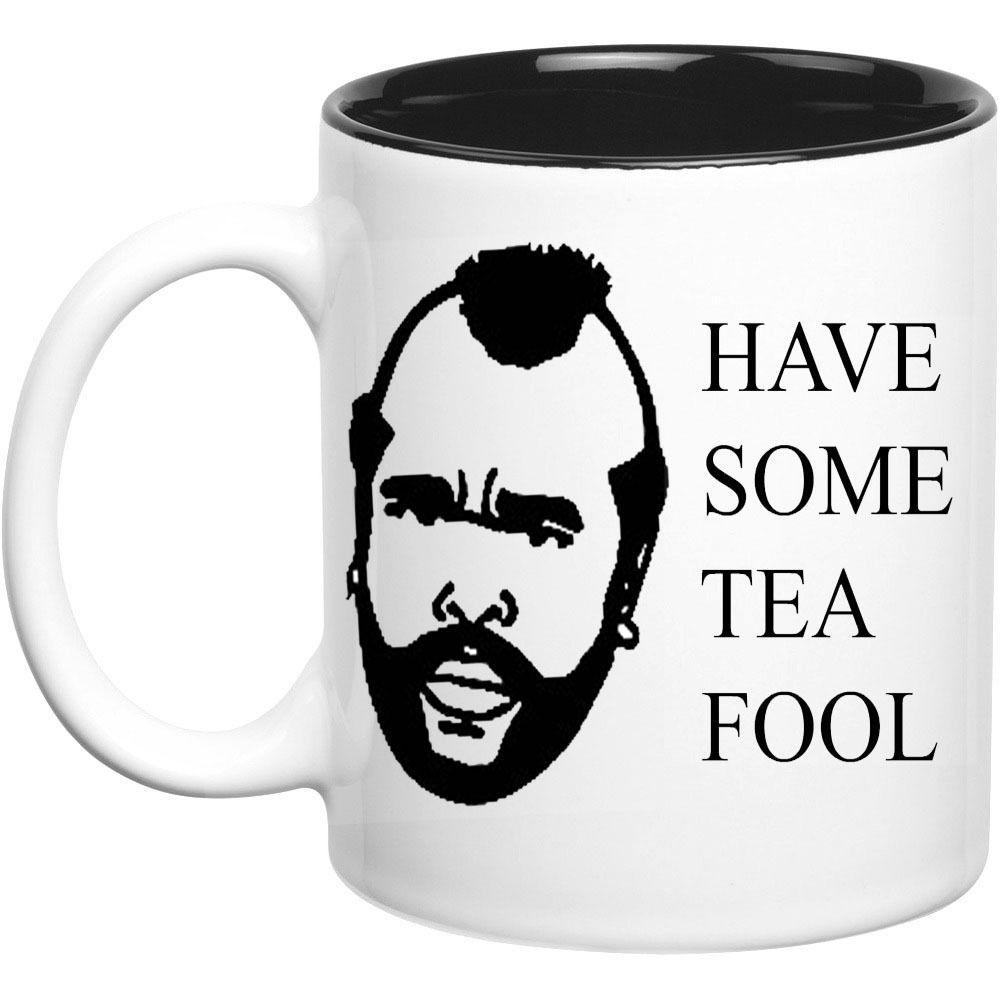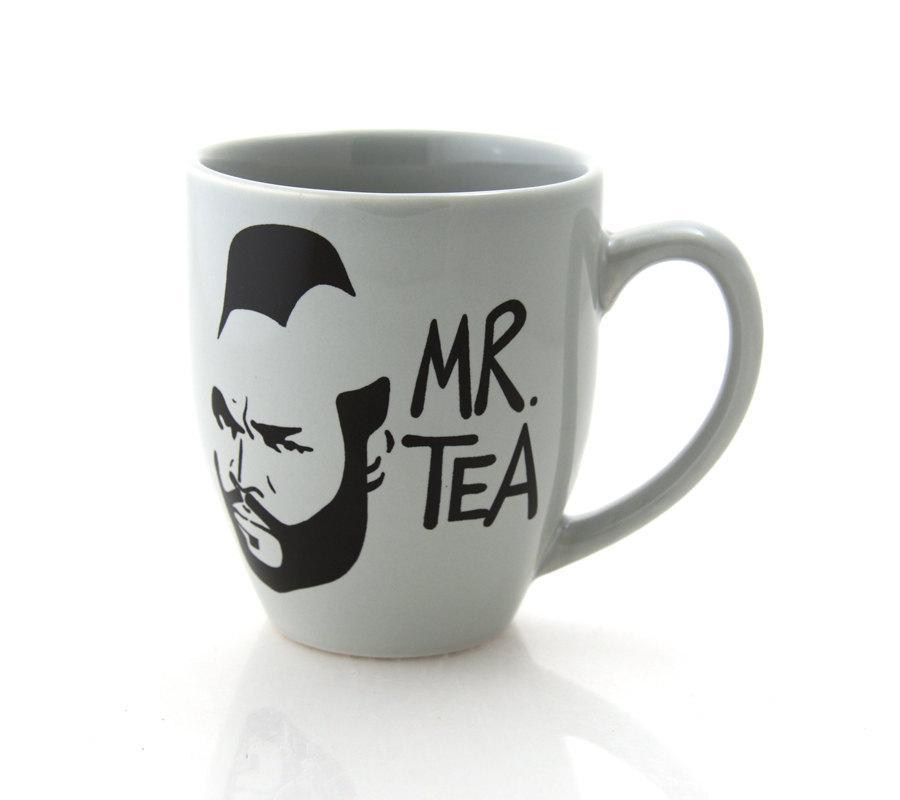The first image is the image on the left, the second image is the image on the right. Analyze the images presented: Is the assertion "The combined images contain exactly two mugs, with handles facing opposite directions and a face on each mug." valid? Answer yes or no. Yes. The first image is the image on the left, the second image is the image on the right. Examine the images to the left and right. Is the description "One cup is in each image, each decorated with the same person's head, but the cup handles are in opposite directions." accurate? Answer yes or no. Yes. 